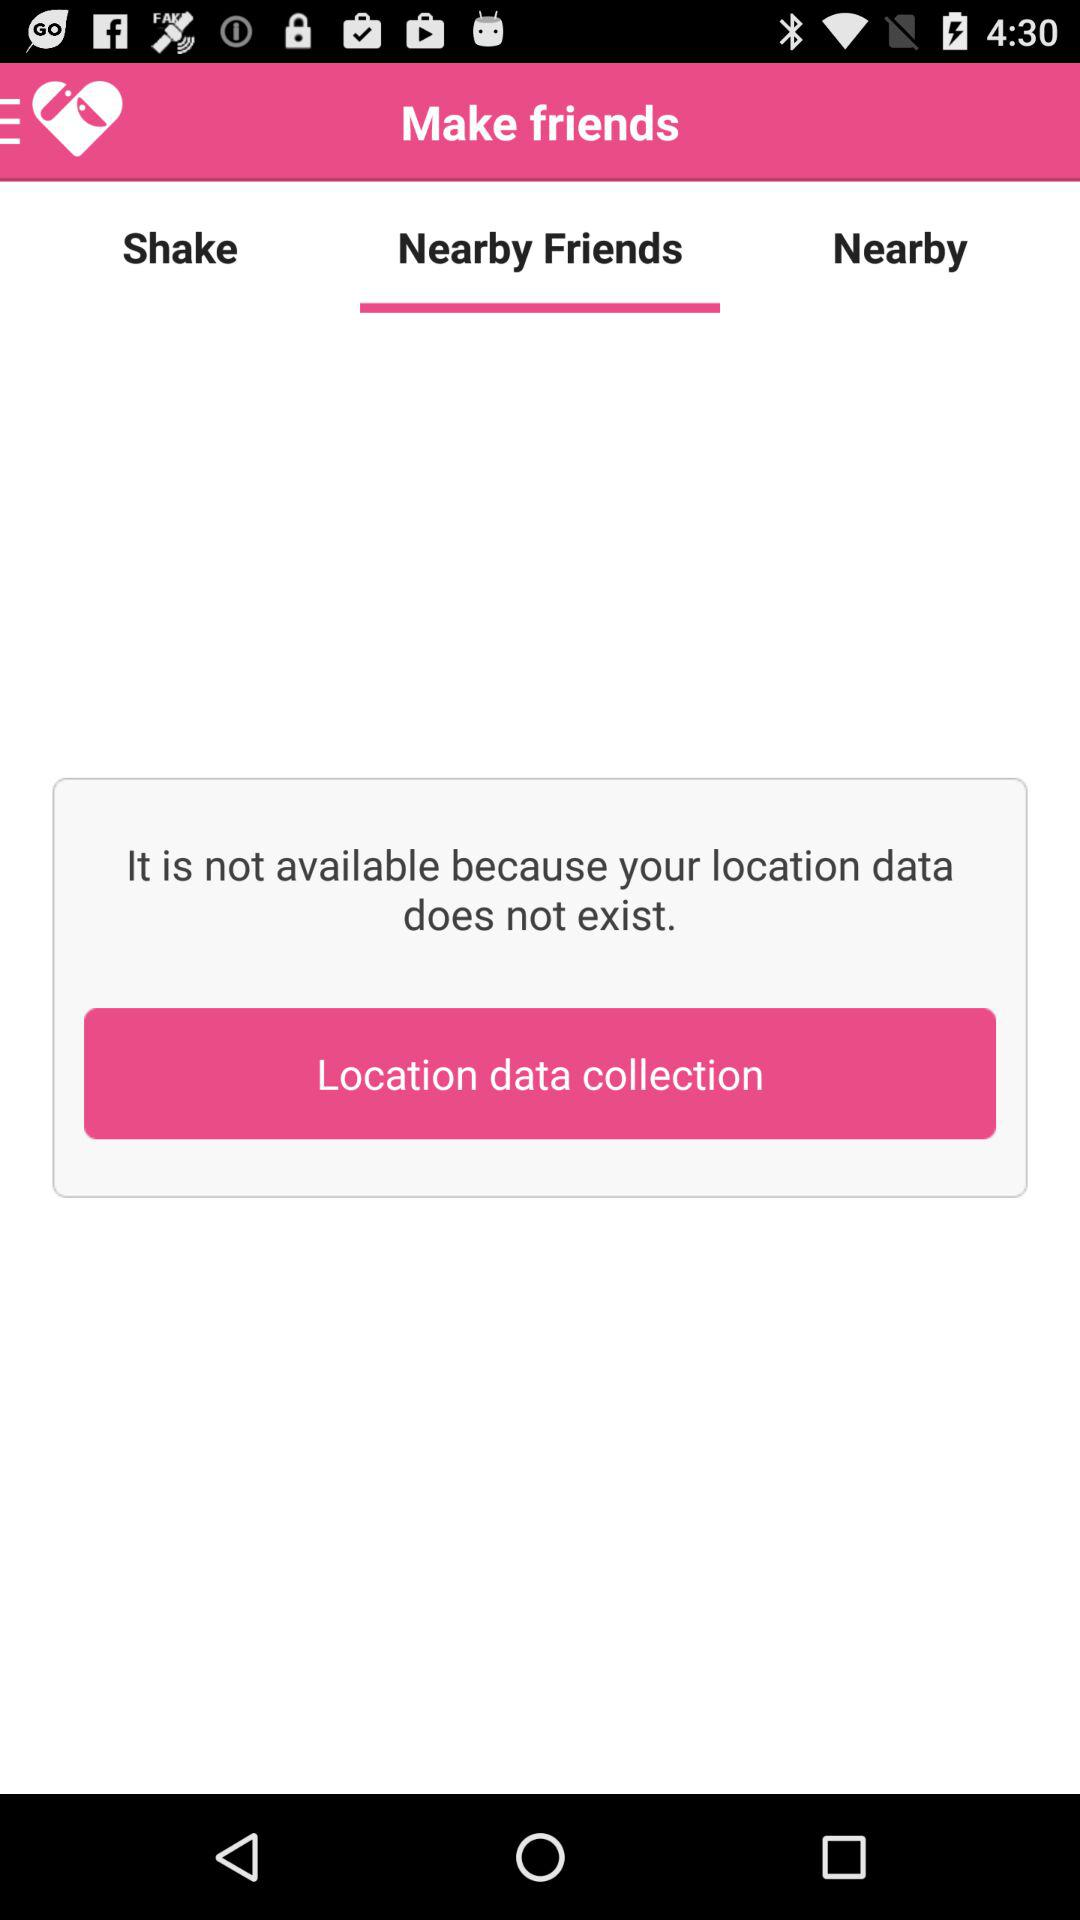Which friends live nearby?
When the provided information is insufficient, respond with <no answer>. <no answer> 